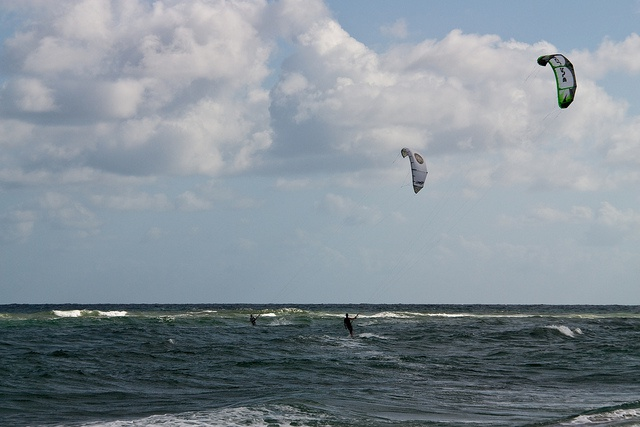Describe the objects in this image and their specific colors. I can see kite in darkgray, black, gray, and darkgreen tones, kite in darkgray, gray, and black tones, people in darkgray, black, gray, and purple tones, people in darkgray, black, gray, and purple tones, and surfboard in darkgray, black, and purple tones in this image. 